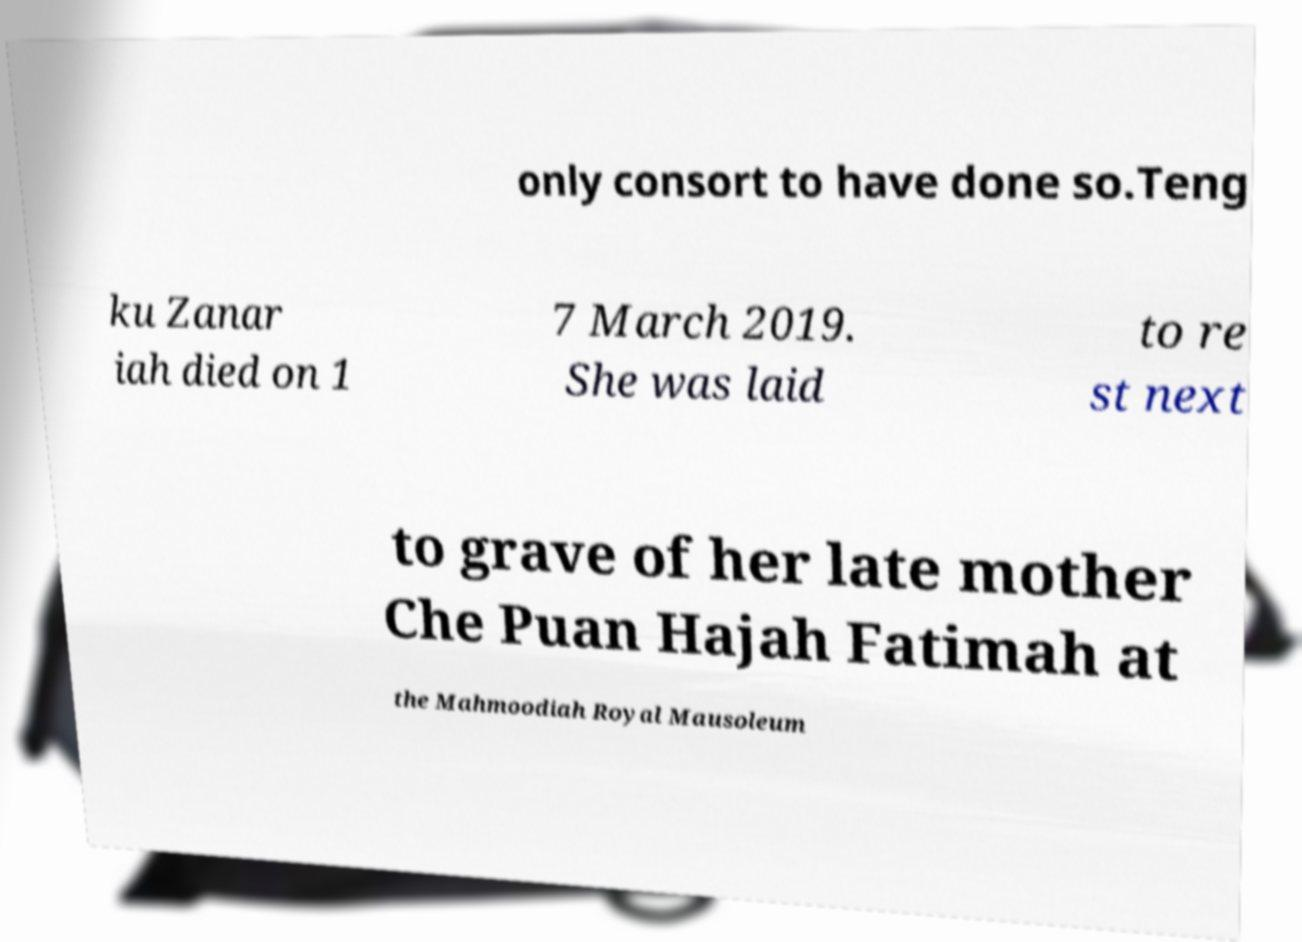Please read and relay the text visible in this image. What does it say? only consort to have done so.Teng ku Zanar iah died on 1 7 March 2019. She was laid to re st next to grave of her late mother Che Puan Hajah Fatimah at the Mahmoodiah Royal Mausoleum 